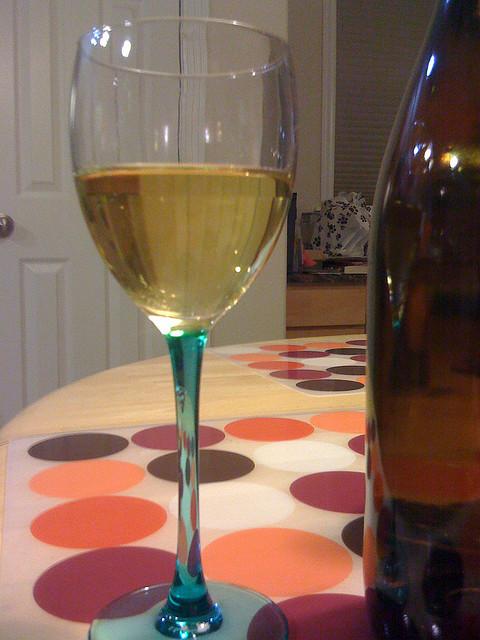What pattern is on the tablecloth?
Quick response, please. Circles. Is the bottle full of liquid?
Be succinct. No. What color is the table?
Give a very brief answer. Polka dot. What is the table made of?
Be succinct. Wood. What is holding the wine glasses?
Concise answer only. Table. What type of beverage is in the glass?
Write a very short answer. Wine. 